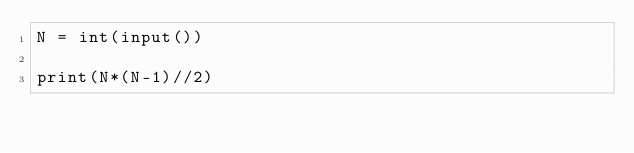Convert code to text. <code><loc_0><loc_0><loc_500><loc_500><_Python_>N = int(input())

print(N*(N-1)//2)</code> 